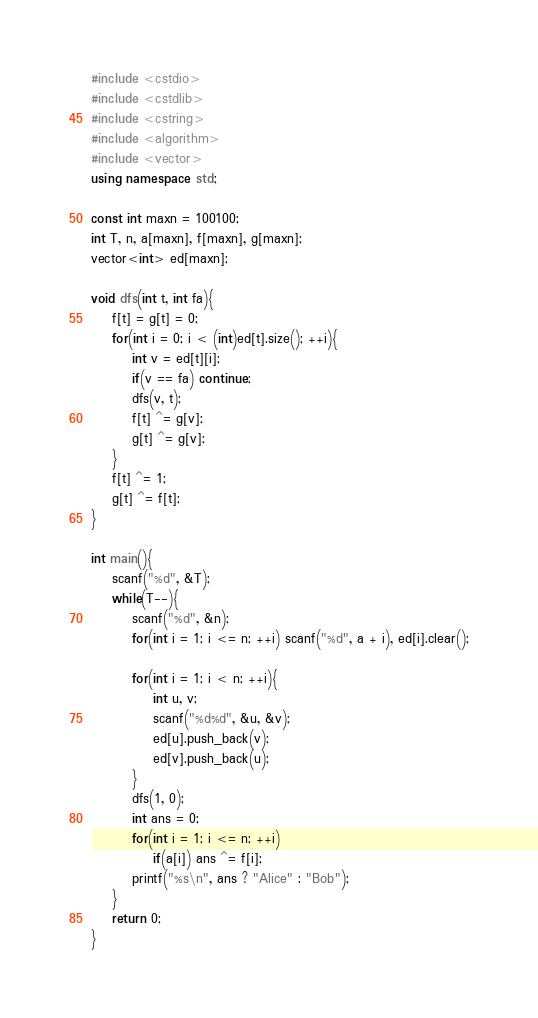Convert code to text. <code><loc_0><loc_0><loc_500><loc_500><_C++_>#include <cstdio>
#include <cstdlib>
#include <cstring>
#include <algorithm>
#include <vector>
using namespace std;
 
const int maxn = 100100;
int T, n, a[maxn], f[maxn], g[maxn];
vector<int> ed[maxn];
 
void dfs(int t, int fa){
    f[t] = g[t] = 0;
    for(int i = 0; i < (int)ed[t].size(); ++i){
        int v = ed[t][i];
        if(v == fa) continue;
        dfs(v, t);
        f[t] ^= g[v];  
        g[t] ^= g[v];
    }
    f[t] ^= 1;
    g[t] ^= f[t];
}
 
int main(){
    scanf("%d", &T);
    while(T--){
        scanf("%d", &n);
        for(int i = 1; i <= n; ++i) scanf("%d", a + i), ed[i].clear();
 
        for(int i = 1; i < n; ++i){
            int u, v;
            scanf("%d%d", &u, &v);
            ed[u].push_back(v);
            ed[v].push_back(u);
        }
        dfs(1, 0);
        int ans = 0;
        for(int i = 1; i <= n; ++i)
            if(a[i]) ans ^= f[i];
        printf("%s\n", ans ? "Alice" : "Bob");
    }
    return 0;  
}
</code> 